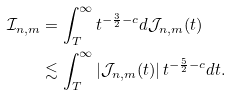Convert formula to latex. <formula><loc_0><loc_0><loc_500><loc_500>\mathcal { I } _ { n , m } & = \int _ { T } ^ { \infty } t ^ { - \frac { 3 } { 2 } - c } d \mathcal { J } _ { n , m } ( t ) \\ & \lesssim \int _ { T } ^ { \infty } | \mathcal { J } _ { n , m } ( t ) | \, t ^ { - \frac { 5 } { 2 } - c } d t .</formula> 